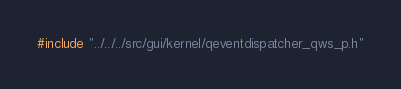<code> <loc_0><loc_0><loc_500><loc_500><_C_>#include "../../../src/gui/kernel/qeventdispatcher_qws_p.h"
</code> 